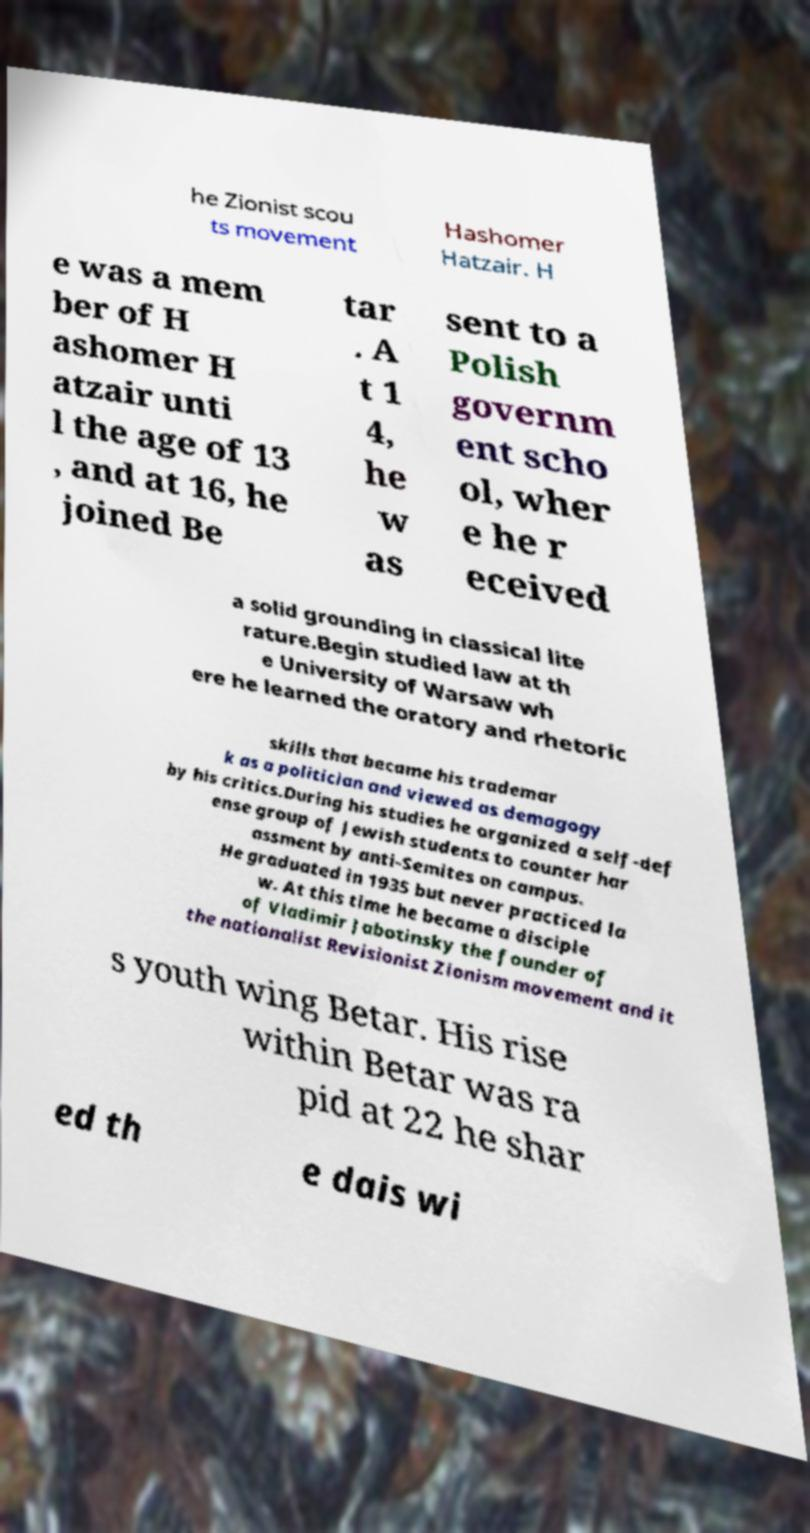I need the written content from this picture converted into text. Can you do that? he Zionist scou ts movement Hashomer Hatzair. H e was a mem ber of H ashomer H atzair unti l the age of 13 , and at 16, he joined Be tar . A t 1 4, he w as sent to a Polish governm ent scho ol, wher e he r eceived a solid grounding in classical lite rature.Begin studied law at th e University of Warsaw wh ere he learned the oratory and rhetoric skills that became his trademar k as a politician and viewed as demagogy by his critics.During his studies he organized a self-def ense group of Jewish students to counter har assment by anti-Semites on campus. He graduated in 1935 but never practiced la w. At this time he became a disciple of Vladimir Jabotinsky the founder of the nationalist Revisionist Zionism movement and it s youth wing Betar. His rise within Betar was ra pid at 22 he shar ed th e dais wi 